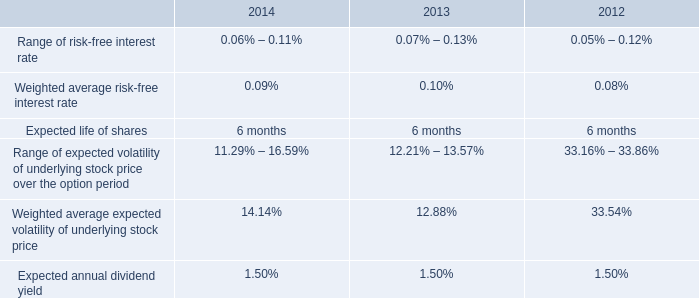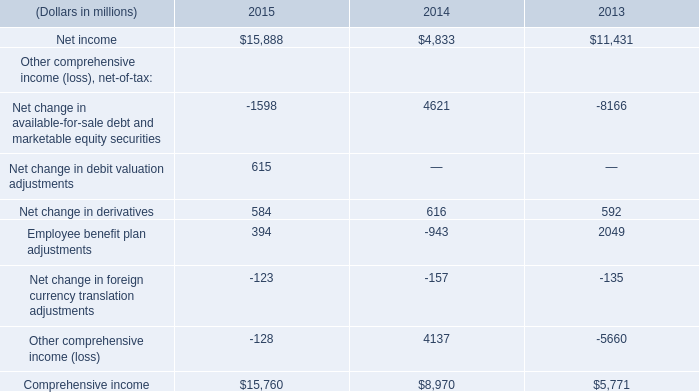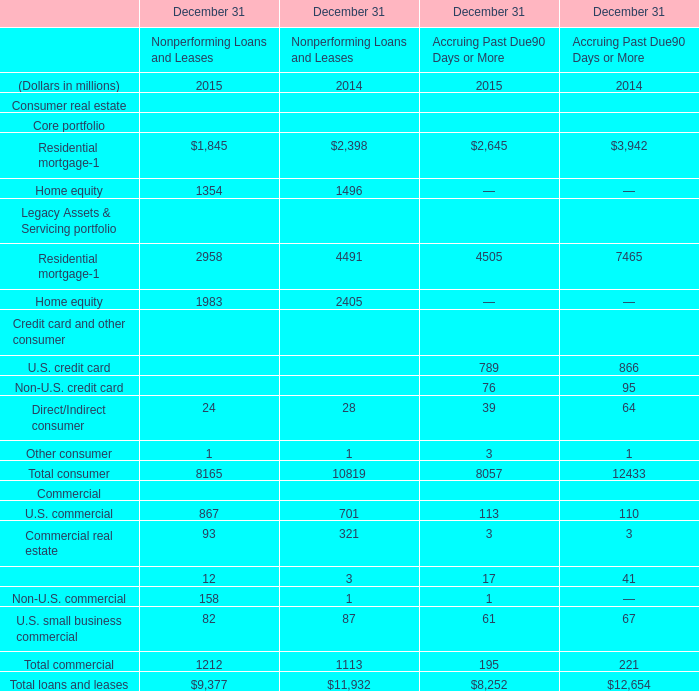what is the growth rate in the weighted average fair value per share of espp share purchase options from 2013 to 2014? 
Computations: ((14.83 - 13.42) / 13.42)
Answer: 0.10507. 